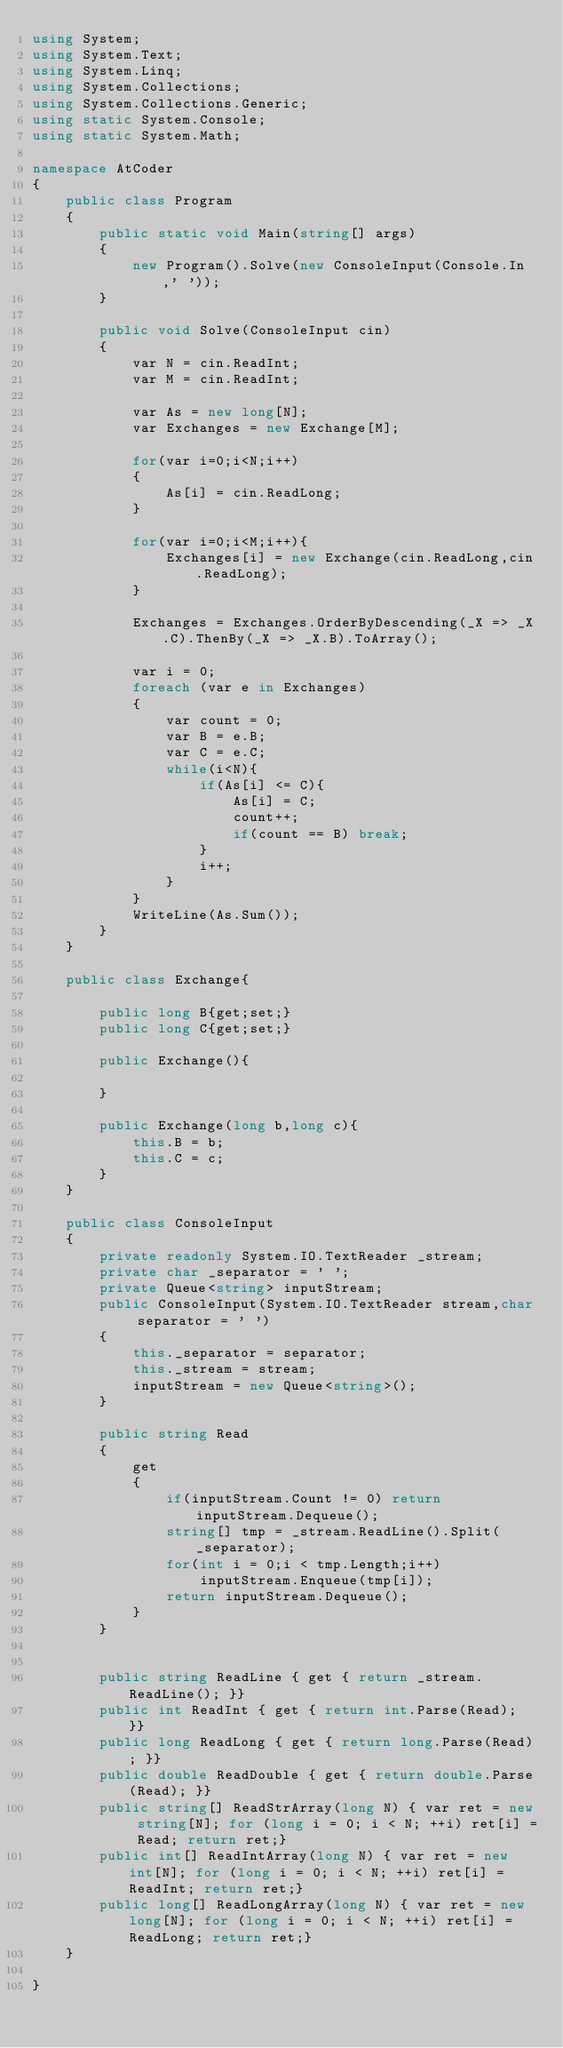Convert code to text. <code><loc_0><loc_0><loc_500><loc_500><_C#_>using System;
using System.Text;
using System.Linq;
using System.Collections;
using System.Collections.Generic;
using static System.Console;
using static System.Math;

namespace AtCoder
{
    public class Program
    {
        public static void Main(string[] args)
        {
            new Program().Solve(new ConsoleInput(Console.In,' '));
        }

        public void Solve(ConsoleInput cin)
        {
            var N = cin.ReadInt;
            var M = cin.ReadInt;

            var As = new long[N];
            var Exchanges = new Exchange[M];

            for(var i=0;i<N;i++)
            {
                As[i] = cin.ReadLong;
            } 

            for(var i=0;i<M;i++){
                Exchanges[i] = new Exchange(cin.ReadLong,cin.ReadLong);
            }

            Exchanges = Exchanges.OrderByDescending(_X => _X.C).ThenBy(_X => _X.B).ToArray();

            var i = 0;
            foreach (var e in Exchanges)
            {
                var count = 0;
                var B = e.B;
                var C = e.C;
                while(i<N){
                    if(As[i] <= C){
                        As[i] = C;
                        count++;
                        if(count == B) break;
                    }
                    i++;
                }
            }
            WriteLine(As.Sum());
        }
    }

    public class Exchange{

        public long B{get;set;}
        public long C{get;set;}

        public Exchange(){

        }
        
        public Exchange(long b,long c){
            this.B = b;
            this.C = c;            
        }
    }

    public class ConsoleInput
    {
        private readonly System.IO.TextReader _stream;
        private char _separator = ' ';
        private Queue<string> inputStream;
        public ConsoleInput(System.IO.TextReader stream,char separator = ' ')
        {
            this._separator = separator;
            this._stream = stream;
            inputStream = new Queue<string>();
        }

        public string Read
        {
            get
            {
                if(inputStream.Count != 0) return inputStream.Dequeue();
                string[] tmp = _stream.ReadLine().Split(_separator);
                for(int i = 0;i < tmp.Length;i++)
                    inputStream.Enqueue(tmp[i]);
                return inputStream.Dequeue();
            }
        }

        
        public string ReadLine { get { return _stream.ReadLine(); }}
        public int ReadInt { get { return int.Parse(Read); }}
        public long ReadLong { get { return long.Parse(Read); }}
        public double ReadDouble { get { return double.Parse(Read); }}
        public string[] ReadStrArray(long N) { var ret = new string[N]; for (long i = 0; i < N; ++i) ret[i] = Read; return ret;}
        public int[] ReadIntArray(long N) { var ret = new int[N]; for (long i = 0; i < N; ++i) ret[i] = ReadInt; return ret;}
        public long[] ReadLongArray(long N) { var ret = new long[N]; for (long i = 0; i < N; ++i) ret[i] = ReadLong; return ret;}
    }

}
</code> 